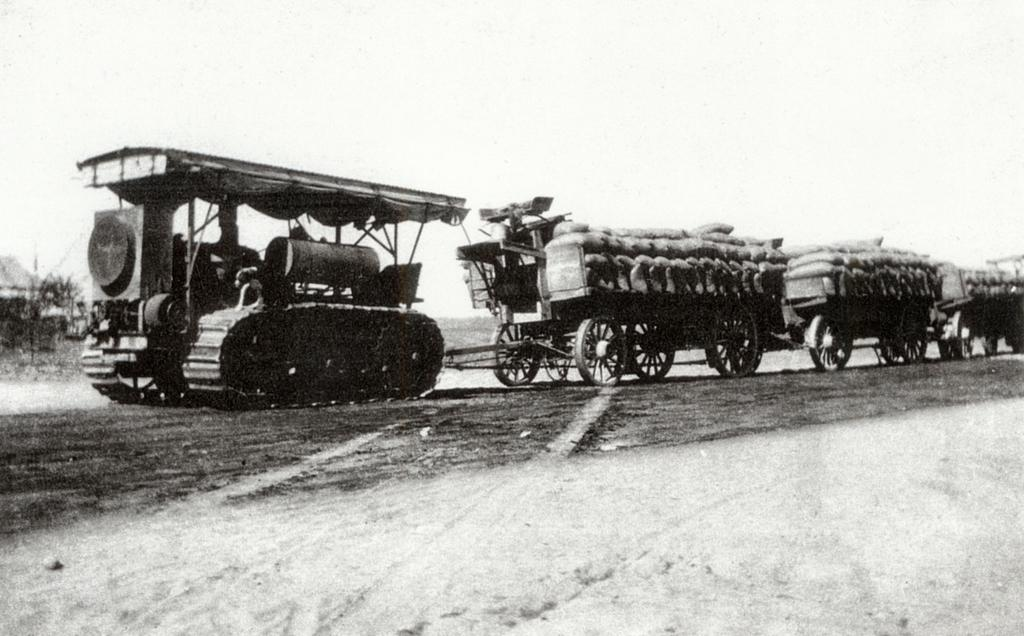What type of image is the photograph in the image? The image is a black and white photograph. What can be seen in the photograph? There is a vehicle in the photograph. What else is present in the photograph besides the vehicle? There are bags in the photograph. What month is it in the photograph? The photograph does not provide any information about the month; it is a black and white image with a vehicle and bags. 